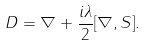Convert formula to latex. <formula><loc_0><loc_0><loc_500><loc_500>D = \nabla + \frac { i \lambda } { 2 } [ \nabla , S ] .</formula> 